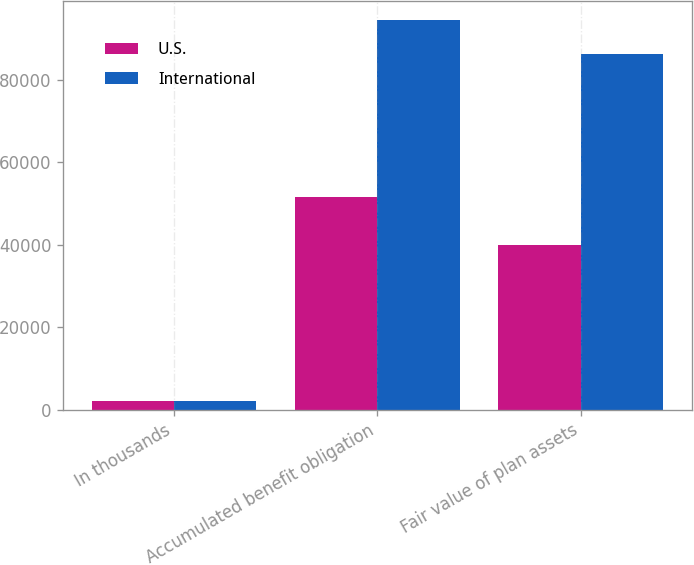Convert chart to OTSL. <chart><loc_0><loc_0><loc_500><loc_500><stacked_bar_chart><ecel><fcel>In thousands<fcel>Accumulated benefit obligation<fcel>Fair value of plan assets<nl><fcel>U.S.<fcel>2011<fcel>51735<fcel>39951<nl><fcel>International<fcel>2011<fcel>94505<fcel>86199<nl></chart> 